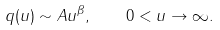<formula> <loc_0><loc_0><loc_500><loc_500>q ( u ) \sim A u ^ { \beta } , \quad 0 < u \to \infty .</formula> 